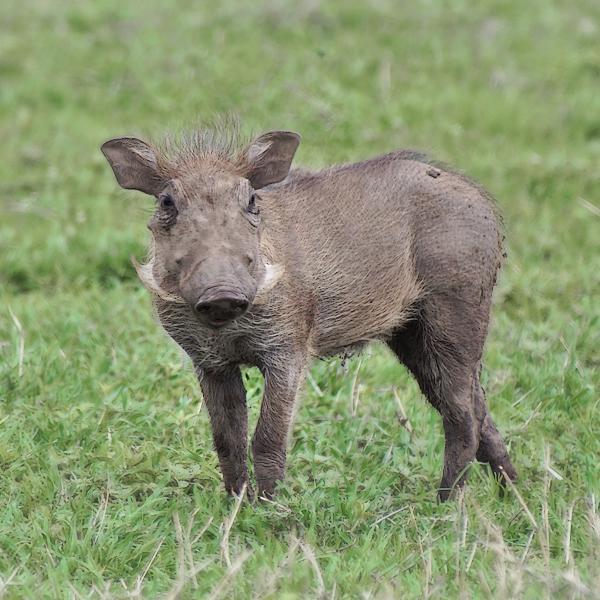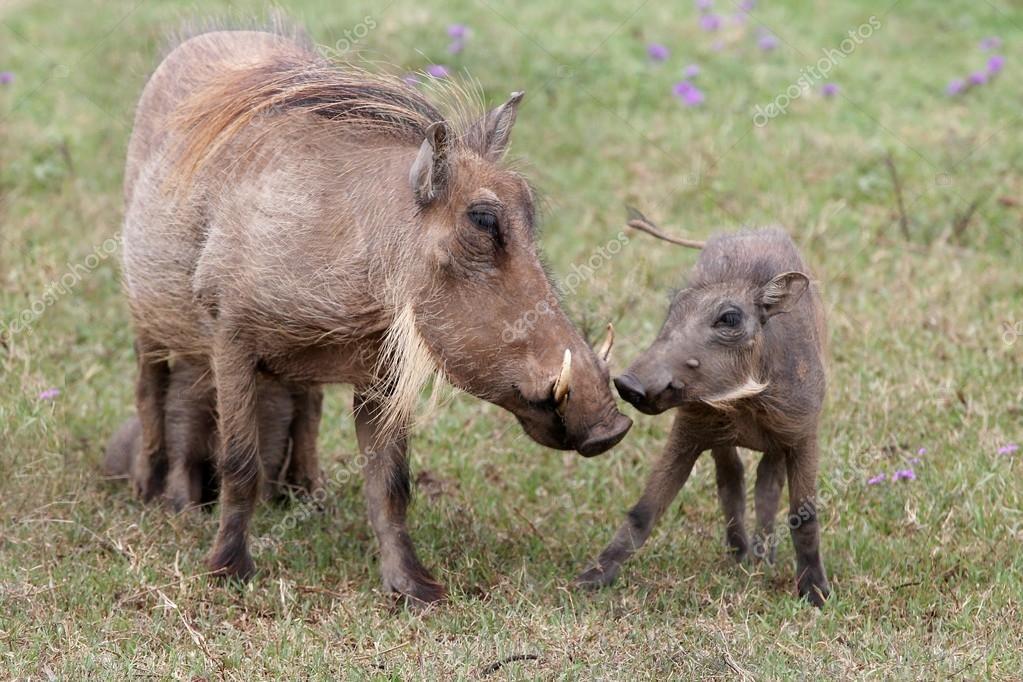The first image is the image on the left, the second image is the image on the right. Considering the images on both sides, is "More than one warthog is present in one of the images." valid? Answer yes or no. Yes. 